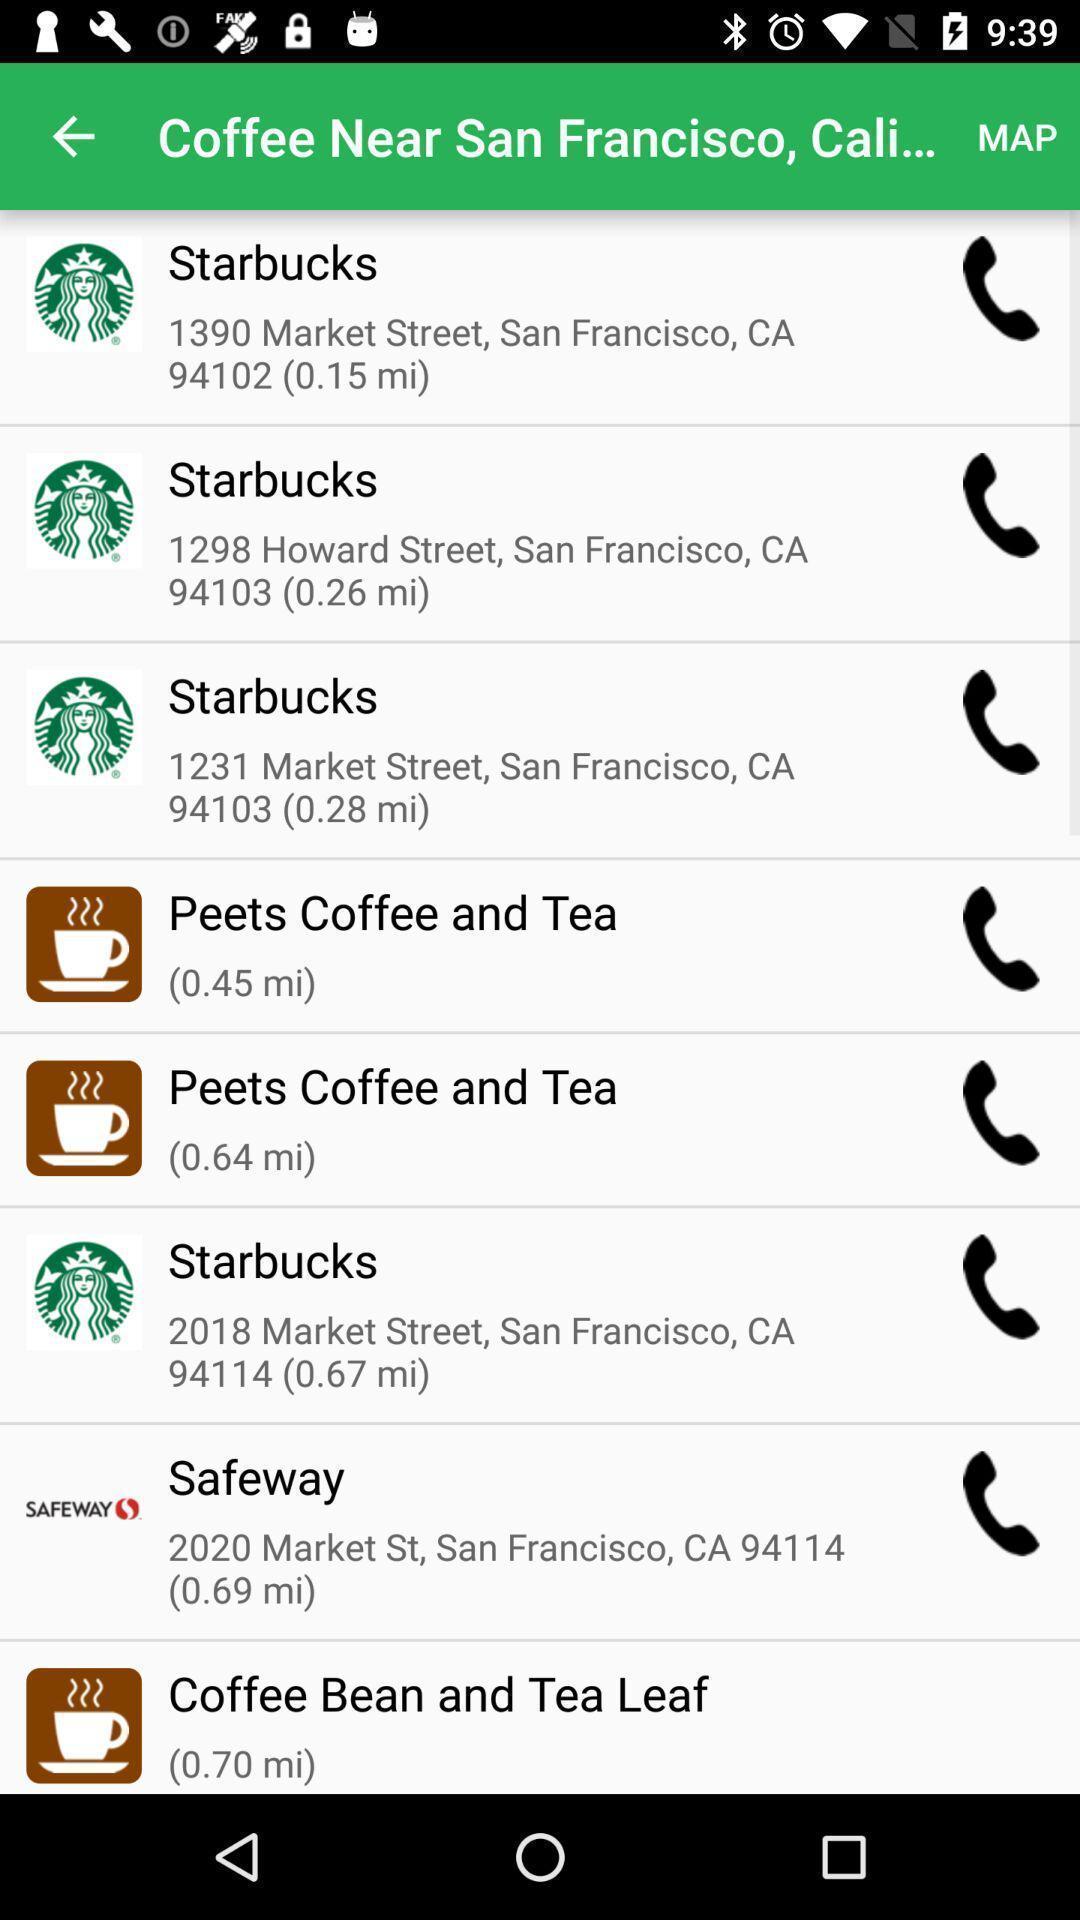Provide a description of this screenshot. Screen displaying call log. 